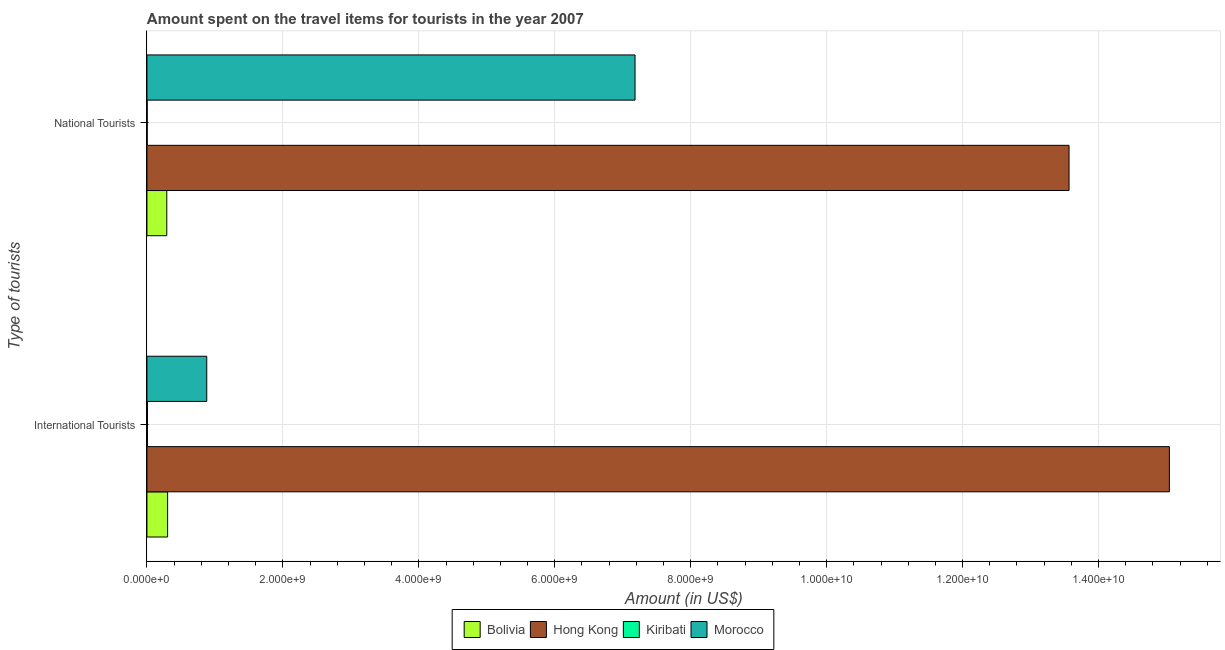How many different coloured bars are there?
Your answer should be compact. 4. How many groups of bars are there?
Your answer should be very brief. 2. How many bars are there on the 2nd tick from the top?
Provide a succinct answer. 4. What is the label of the 2nd group of bars from the top?
Your answer should be very brief. International Tourists. What is the amount spent on travel items of national tourists in Kiribati?
Your response must be concise. 3.80e+06. Across all countries, what is the maximum amount spent on travel items of national tourists?
Provide a short and direct response. 1.36e+1. Across all countries, what is the minimum amount spent on travel items of national tourists?
Your answer should be compact. 3.80e+06. In which country was the amount spent on travel items of international tourists maximum?
Provide a short and direct response. Hong Kong. In which country was the amount spent on travel items of international tourists minimum?
Keep it short and to the point. Kiribati. What is the total amount spent on travel items of international tourists in the graph?
Keep it short and to the point. 1.62e+1. What is the difference between the amount spent on travel items of international tourists in Morocco and that in Bolivia?
Your answer should be very brief. 5.76e+08. What is the difference between the amount spent on travel items of international tourists in Bolivia and the amount spent on travel items of national tourists in Kiribati?
Keep it short and to the point. 3.00e+08. What is the average amount spent on travel items of national tourists per country?
Offer a terse response. 5.26e+09. What is the difference between the amount spent on travel items of national tourists and amount spent on travel items of international tourists in Morocco?
Offer a very short reply. 6.30e+09. What is the ratio of the amount spent on travel items of international tourists in Bolivia to that in Morocco?
Provide a short and direct response. 0.35. Is the amount spent on travel items of international tourists in Bolivia less than that in Kiribati?
Your response must be concise. No. In how many countries, is the amount spent on travel items of national tourists greater than the average amount spent on travel items of national tourists taken over all countries?
Keep it short and to the point. 2. What does the 3rd bar from the top in International Tourists represents?
Offer a very short reply. Hong Kong. How many bars are there?
Ensure brevity in your answer.  8. Are all the bars in the graph horizontal?
Provide a succinct answer. Yes. Are the values on the major ticks of X-axis written in scientific E-notation?
Provide a succinct answer. Yes. Does the graph contain any zero values?
Your response must be concise. No. Where does the legend appear in the graph?
Give a very brief answer. Bottom center. What is the title of the graph?
Keep it short and to the point. Amount spent on the travel items for tourists in the year 2007. Does "Turks and Caicos Islands" appear as one of the legend labels in the graph?
Provide a succinct answer. No. What is the label or title of the Y-axis?
Your answer should be compact. Type of tourists. What is the Amount (in US$) in Bolivia in International Tourists?
Your answer should be compact. 3.04e+08. What is the Amount (in US$) in Hong Kong in International Tourists?
Ensure brevity in your answer.  1.50e+1. What is the Amount (in US$) in Kiribati in International Tourists?
Give a very brief answer. 7.80e+06. What is the Amount (in US$) in Morocco in International Tourists?
Keep it short and to the point. 8.80e+08. What is the Amount (in US$) in Bolivia in National Tourists?
Make the answer very short. 2.92e+08. What is the Amount (in US$) of Hong Kong in National Tourists?
Your answer should be compact. 1.36e+1. What is the Amount (in US$) in Kiribati in National Tourists?
Your answer should be compact. 3.80e+06. What is the Amount (in US$) of Morocco in National Tourists?
Your answer should be very brief. 7.18e+09. Across all Type of tourists, what is the maximum Amount (in US$) of Bolivia?
Your response must be concise. 3.04e+08. Across all Type of tourists, what is the maximum Amount (in US$) in Hong Kong?
Ensure brevity in your answer.  1.50e+1. Across all Type of tourists, what is the maximum Amount (in US$) in Kiribati?
Make the answer very short. 7.80e+06. Across all Type of tourists, what is the maximum Amount (in US$) of Morocco?
Ensure brevity in your answer.  7.18e+09. Across all Type of tourists, what is the minimum Amount (in US$) in Bolivia?
Offer a very short reply. 2.92e+08. Across all Type of tourists, what is the minimum Amount (in US$) in Hong Kong?
Provide a short and direct response. 1.36e+1. Across all Type of tourists, what is the minimum Amount (in US$) of Kiribati?
Offer a very short reply. 3.80e+06. Across all Type of tourists, what is the minimum Amount (in US$) of Morocco?
Keep it short and to the point. 8.80e+08. What is the total Amount (in US$) of Bolivia in the graph?
Your answer should be very brief. 5.96e+08. What is the total Amount (in US$) of Hong Kong in the graph?
Make the answer very short. 2.86e+1. What is the total Amount (in US$) in Kiribati in the graph?
Provide a succinct answer. 1.16e+07. What is the total Amount (in US$) of Morocco in the graph?
Your response must be concise. 8.06e+09. What is the difference between the Amount (in US$) of Bolivia in International Tourists and that in National Tourists?
Keep it short and to the point. 1.20e+07. What is the difference between the Amount (in US$) in Hong Kong in International Tourists and that in National Tourists?
Make the answer very short. 1.48e+09. What is the difference between the Amount (in US$) in Kiribati in International Tourists and that in National Tourists?
Keep it short and to the point. 4.00e+06. What is the difference between the Amount (in US$) in Morocco in International Tourists and that in National Tourists?
Keep it short and to the point. -6.30e+09. What is the difference between the Amount (in US$) of Bolivia in International Tourists and the Amount (in US$) of Hong Kong in National Tourists?
Offer a terse response. -1.33e+1. What is the difference between the Amount (in US$) of Bolivia in International Tourists and the Amount (in US$) of Kiribati in National Tourists?
Ensure brevity in your answer.  3.00e+08. What is the difference between the Amount (in US$) in Bolivia in International Tourists and the Amount (in US$) in Morocco in National Tourists?
Ensure brevity in your answer.  -6.88e+09. What is the difference between the Amount (in US$) in Hong Kong in International Tourists and the Amount (in US$) in Kiribati in National Tourists?
Your response must be concise. 1.50e+1. What is the difference between the Amount (in US$) of Hong Kong in International Tourists and the Amount (in US$) of Morocco in National Tourists?
Your answer should be compact. 7.86e+09. What is the difference between the Amount (in US$) of Kiribati in International Tourists and the Amount (in US$) of Morocco in National Tourists?
Offer a very short reply. -7.17e+09. What is the average Amount (in US$) in Bolivia per Type of tourists?
Provide a succinct answer. 2.98e+08. What is the average Amount (in US$) in Hong Kong per Type of tourists?
Provide a succinct answer. 1.43e+1. What is the average Amount (in US$) in Kiribati per Type of tourists?
Provide a short and direct response. 5.80e+06. What is the average Amount (in US$) of Morocco per Type of tourists?
Give a very brief answer. 4.03e+09. What is the difference between the Amount (in US$) in Bolivia and Amount (in US$) in Hong Kong in International Tourists?
Make the answer very short. -1.47e+1. What is the difference between the Amount (in US$) in Bolivia and Amount (in US$) in Kiribati in International Tourists?
Provide a succinct answer. 2.96e+08. What is the difference between the Amount (in US$) of Bolivia and Amount (in US$) of Morocco in International Tourists?
Your response must be concise. -5.76e+08. What is the difference between the Amount (in US$) in Hong Kong and Amount (in US$) in Kiribati in International Tourists?
Offer a terse response. 1.50e+1. What is the difference between the Amount (in US$) in Hong Kong and Amount (in US$) in Morocco in International Tourists?
Offer a very short reply. 1.42e+1. What is the difference between the Amount (in US$) of Kiribati and Amount (in US$) of Morocco in International Tourists?
Provide a succinct answer. -8.72e+08. What is the difference between the Amount (in US$) in Bolivia and Amount (in US$) in Hong Kong in National Tourists?
Provide a succinct answer. -1.33e+1. What is the difference between the Amount (in US$) in Bolivia and Amount (in US$) in Kiribati in National Tourists?
Your response must be concise. 2.88e+08. What is the difference between the Amount (in US$) of Bolivia and Amount (in US$) of Morocco in National Tourists?
Your answer should be compact. -6.89e+09. What is the difference between the Amount (in US$) in Hong Kong and Amount (in US$) in Kiribati in National Tourists?
Provide a short and direct response. 1.36e+1. What is the difference between the Amount (in US$) in Hong Kong and Amount (in US$) in Morocco in National Tourists?
Your answer should be very brief. 6.38e+09. What is the difference between the Amount (in US$) of Kiribati and Amount (in US$) of Morocco in National Tourists?
Ensure brevity in your answer.  -7.18e+09. What is the ratio of the Amount (in US$) in Bolivia in International Tourists to that in National Tourists?
Provide a succinct answer. 1.04. What is the ratio of the Amount (in US$) in Hong Kong in International Tourists to that in National Tourists?
Keep it short and to the point. 1.11. What is the ratio of the Amount (in US$) of Kiribati in International Tourists to that in National Tourists?
Your answer should be very brief. 2.05. What is the ratio of the Amount (in US$) in Morocco in International Tourists to that in National Tourists?
Your answer should be compact. 0.12. What is the difference between the highest and the second highest Amount (in US$) of Hong Kong?
Keep it short and to the point. 1.48e+09. What is the difference between the highest and the second highest Amount (in US$) in Kiribati?
Give a very brief answer. 4.00e+06. What is the difference between the highest and the second highest Amount (in US$) of Morocco?
Provide a short and direct response. 6.30e+09. What is the difference between the highest and the lowest Amount (in US$) in Bolivia?
Offer a terse response. 1.20e+07. What is the difference between the highest and the lowest Amount (in US$) in Hong Kong?
Provide a succinct answer. 1.48e+09. What is the difference between the highest and the lowest Amount (in US$) in Morocco?
Keep it short and to the point. 6.30e+09. 